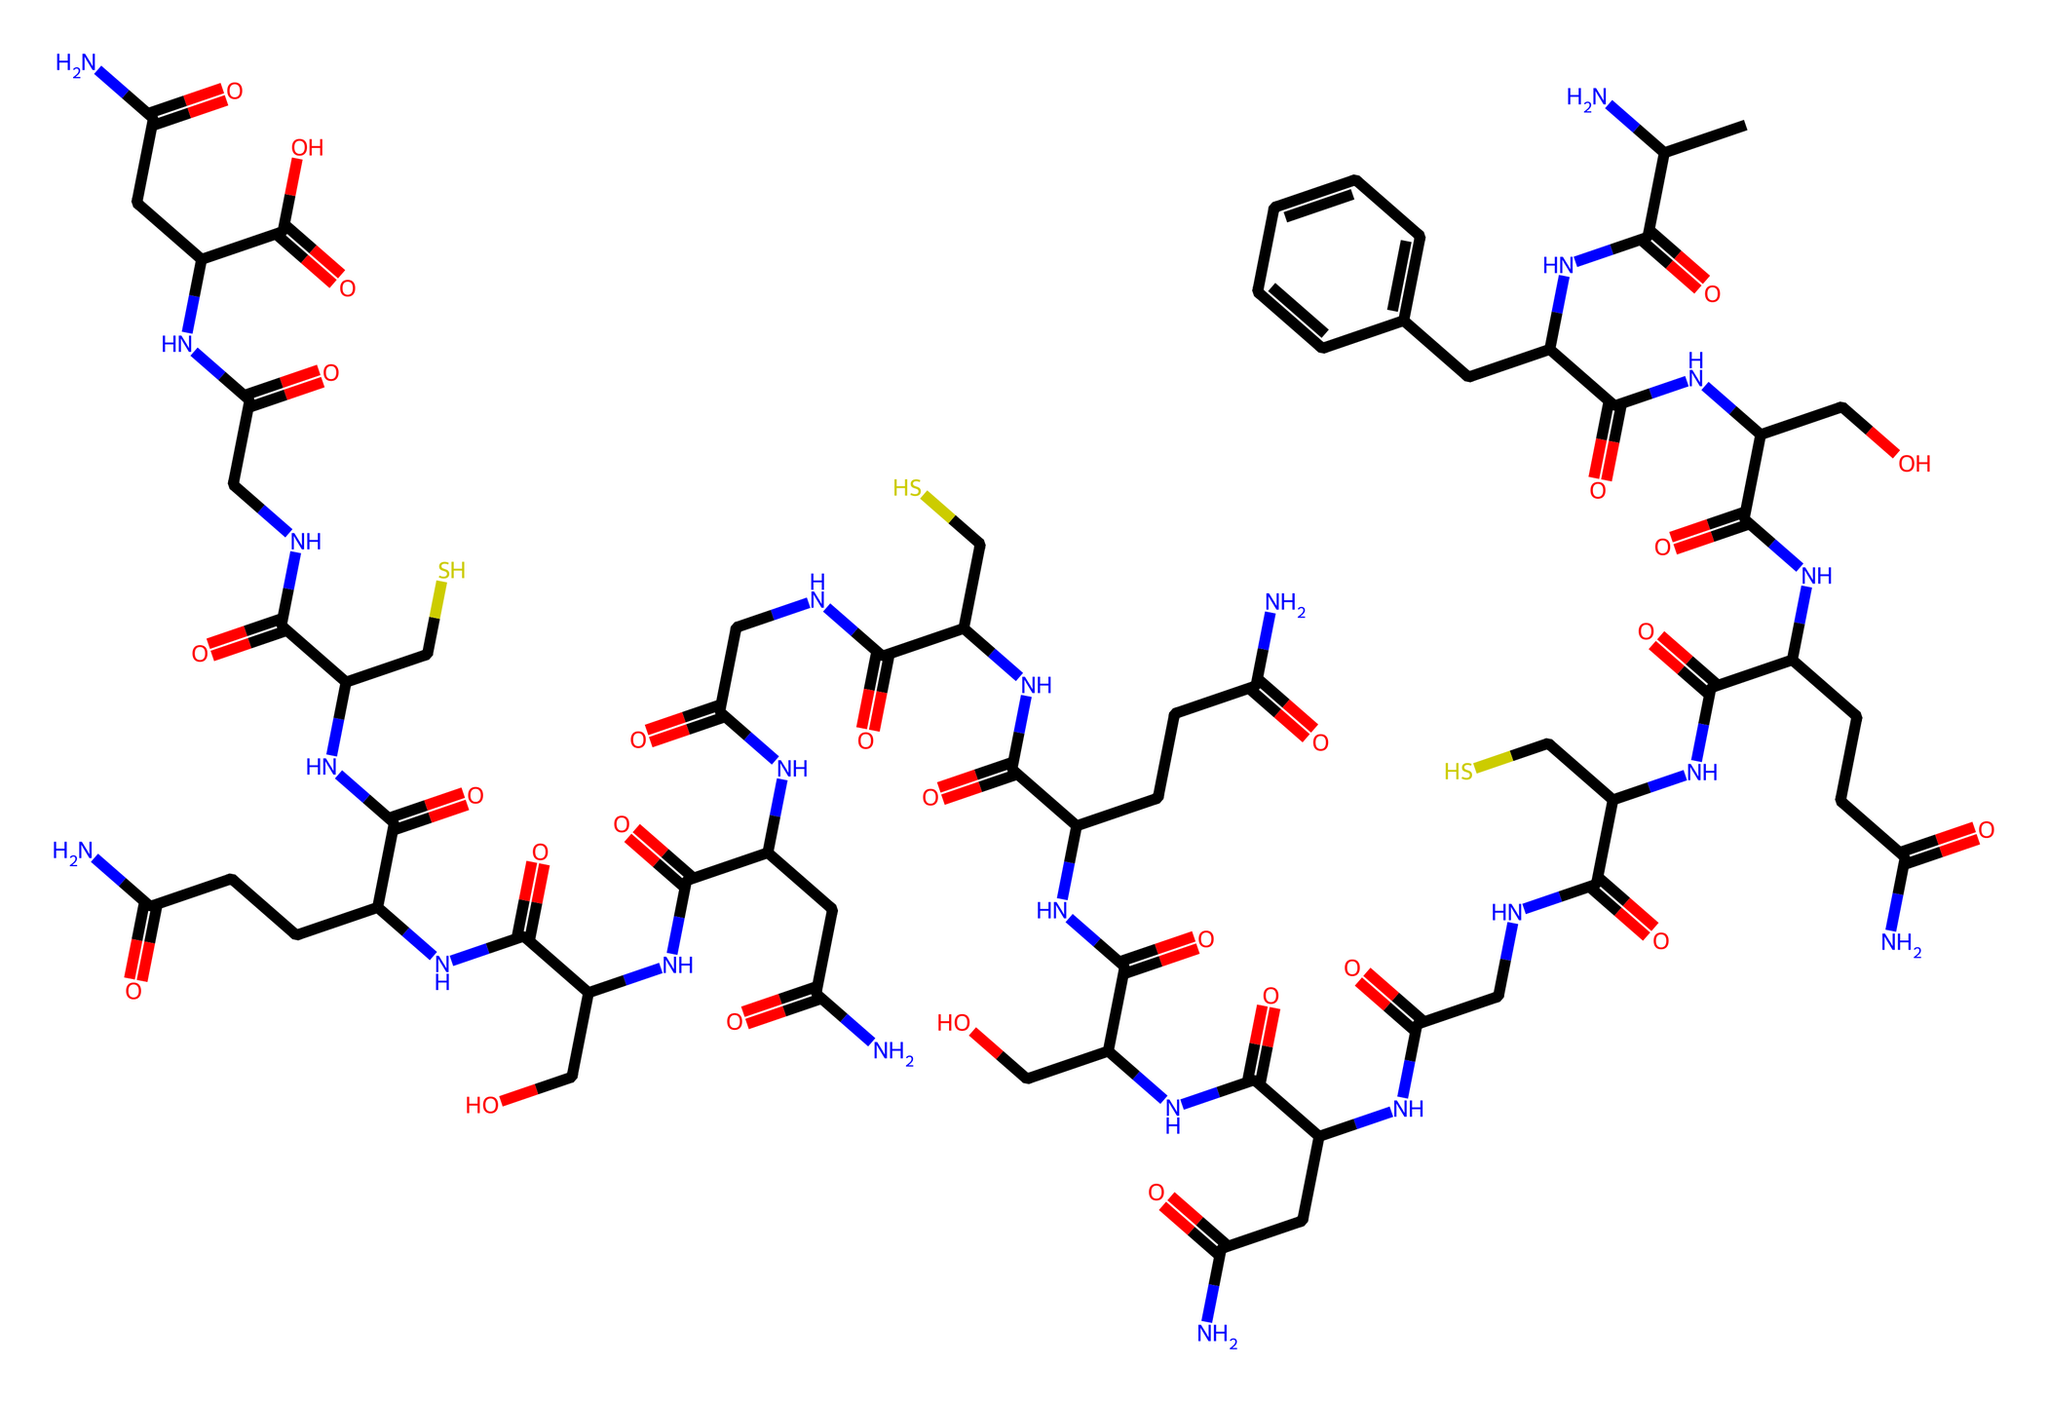What is the primary functional group present in this chemical structure? The chemical structure contains amide bonds evident from the "NC" segments, indicating the presence of amide functional groups.
Answer: amide How many carbon atoms are present in this structure? By analyzing the SMILES, we can identify and count the occurrences of 'C', which represent carbon atoms in the chemical structure. There are 27 carbon atoms present.
Answer: 27 What is the total number of nitrogen atoms in this molecule? The nitrogen atoms can be counted by identifying the 'N' in the SMILES, which indicates the presence of nitrogen in the structure. There are 10 nitrogen atoms in total.
Answer: 10 Does this structure contain any thiol groups? By examining the structure for the presence of 'S', we can observe that there are sulfur atoms connected to other elements, indicating there are thiol groups in the molecule.
Answer: yes What is the structure predominantly composed of, in terms of macromolecule category? The presence of multiple amino acid residues linked through peptide bonds suggests that this structure is predominantly a protein, specifically collagen.
Answer: protein Which part of the structure indicates the presence of hydroxyl groups? The segments represented by "C(CO)" where 'O' is notable, indicates hydroxyl groups due to the presence of the -OH functional group.
Answer: hydroxyl groups 